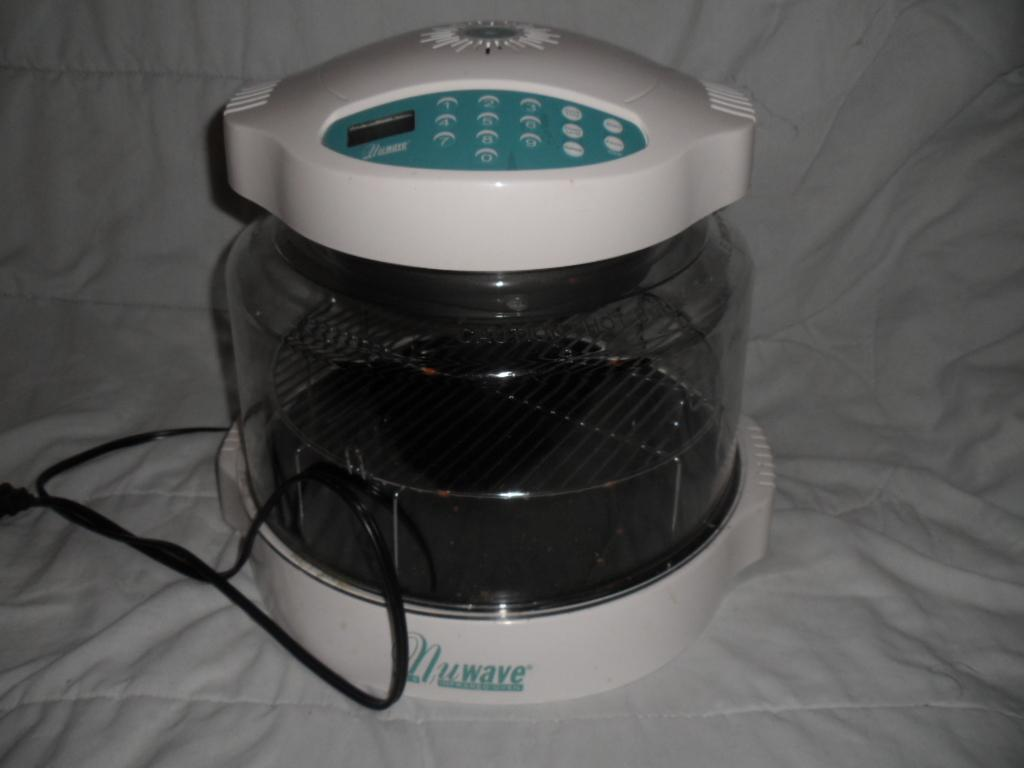<image>
Relay a brief, clear account of the picture shown. an appliance that has the word nuwave written on it 